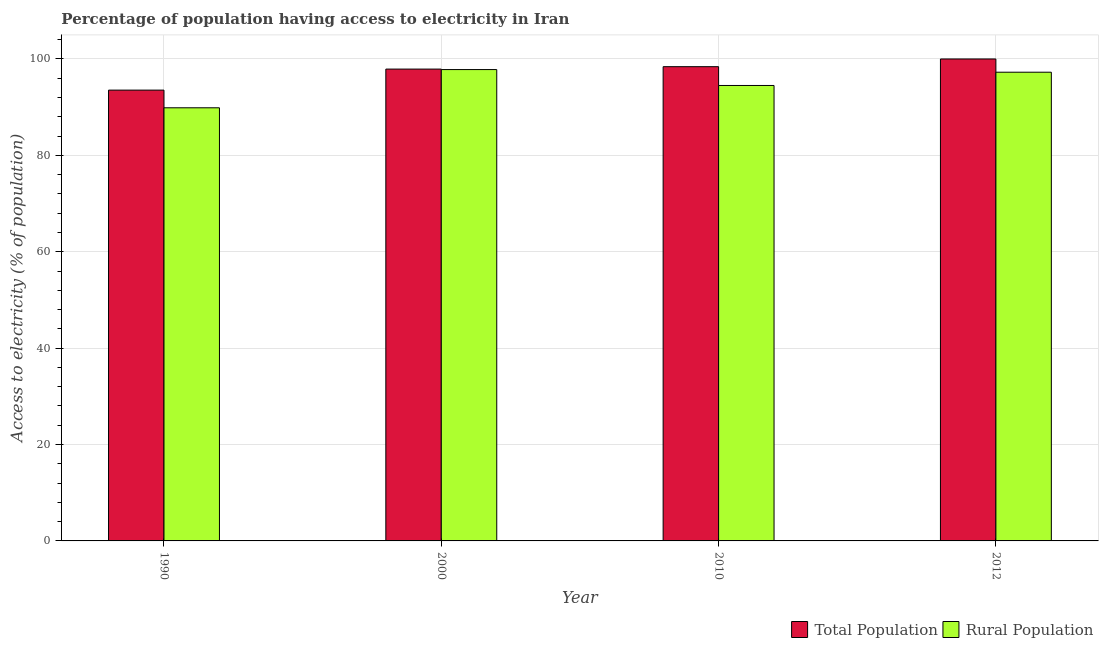Are the number of bars per tick equal to the number of legend labels?
Your answer should be compact. Yes. Are the number of bars on each tick of the X-axis equal?
Your answer should be very brief. Yes. How many bars are there on the 4th tick from the left?
Your answer should be very brief. 2. How many bars are there on the 4th tick from the right?
Make the answer very short. 2. What is the label of the 1st group of bars from the left?
Your answer should be very brief. 1990. What is the percentage of rural population having access to electricity in 2012?
Your answer should be compact. 97.25. Across all years, what is the maximum percentage of population having access to electricity?
Offer a very short reply. 100. Across all years, what is the minimum percentage of rural population having access to electricity?
Offer a very short reply. 89.87. In which year was the percentage of rural population having access to electricity maximum?
Your response must be concise. 2000. What is the total percentage of population having access to electricity in the graph?
Offer a terse response. 389.84. What is the difference between the percentage of rural population having access to electricity in 1990 and that in 2010?
Provide a short and direct response. -4.63. What is the difference between the percentage of population having access to electricity in 1990 and the percentage of rural population having access to electricity in 2010?
Give a very brief answer. -4.86. What is the average percentage of population having access to electricity per year?
Your answer should be compact. 97.46. In how many years, is the percentage of rural population having access to electricity greater than 4 %?
Keep it short and to the point. 4. What is the ratio of the percentage of rural population having access to electricity in 1990 to that in 2012?
Your answer should be very brief. 0.92. Is the difference between the percentage of rural population having access to electricity in 1990 and 2000 greater than the difference between the percentage of population having access to electricity in 1990 and 2000?
Offer a very short reply. No. What is the difference between the highest and the second highest percentage of population having access to electricity?
Provide a short and direct response. 1.6. What is the difference between the highest and the lowest percentage of population having access to electricity?
Provide a short and direct response. 6.46. In how many years, is the percentage of population having access to electricity greater than the average percentage of population having access to electricity taken over all years?
Give a very brief answer. 3. What does the 2nd bar from the left in 2010 represents?
Keep it short and to the point. Rural Population. What does the 1st bar from the right in 2010 represents?
Offer a terse response. Rural Population. How many bars are there?
Your answer should be compact. 8. Are all the bars in the graph horizontal?
Offer a terse response. No. How many years are there in the graph?
Your answer should be very brief. 4. Are the values on the major ticks of Y-axis written in scientific E-notation?
Provide a succinct answer. No. Where does the legend appear in the graph?
Ensure brevity in your answer.  Bottom right. How are the legend labels stacked?
Your answer should be very brief. Horizontal. What is the title of the graph?
Keep it short and to the point. Percentage of population having access to electricity in Iran. Does "Netherlands" appear as one of the legend labels in the graph?
Your answer should be compact. No. What is the label or title of the Y-axis?
Make the answer very short. Access to electricity (% of population). What is the Access to electricity (% of population) of Total Population in 1990?
Provide a short and direct response. 93.54. What is the Access to electricity (% of population) in Rural Population in 1990?
Keep it short and to the point. 89.87. What is the Access to electricity (% of population) of Total Population in 2000?
Your answer should be compact. 97.9. What is the Access to electricity (% of population) in Rural Population in 2000?
Make the answer very short. 97.8. What is the Access to electricity (% of population) in Total Population in 2010?
Your answer should be compact. 98.4. What is the Access to electricity (% of population) in Rural Population in 2010?
Give a very brief answer. 94.5. What is the Access to electricity (% of population) in Total Population in 2012?
Give a very brief answer. 100. What is the Access to electricity (% of population) in Rural Population in 2012?
Keep it short and to the point. 97.25. Across all years, what is the maximum Access to electricity (% of population) in Total Population?
Offer a terse response. 100. Across all years, what is the maximum Access to electricity (% of population) of Rural Population?
Your response must be concise. 97.8. Across all years, what is the minimum Access to electricity (% of population) in Total Population?
Make the answer very short. 93.54. Across all years, what is the minimum Access to electricity (% of population) in Rural Population?
Your response must be concise. 89.87. What is the total Access to electricity (% of population) of Total Population in the graph?
Your response must be concise. 389.84. What is the total Access to electricity (% of population) in Rural Population in the graph?
Your response must be concise. 379.42. What is the difference between the Access to electricity (% of population) in Total Population in 1990 and that in 2000?
Keep it short and to the point. -4.36. What is the difference between the Access to electricity (% of population) of Rural Population in 1990 and that in 2000?
Your answer should be compact. -7.93. What is the difference between the Access to electricity (% of population) of Total Population in 1990 and that in 2010?
Provide a short and direct response. -4.86. What is the difference between the Access to electricity (% of population) in Rural Population in 1990 and that in 2010?
Provide a short and direct response. -4.63. What is the difference between the Access to electricity (% of population) in Total Population in 1990 and that in 2012?
Provide a short and direct response. -6.46. What is the difference between the Access to electricity (% of population) of Rural Population in 1990 and that in 2012?
Offer a terse response. -7.38. What is the difference between the Access to electricity (% of population) of Rural Population in 2000 and that in 2010?
Your answer should be very brief. 3.3. What is the difference between the Access to electricity (% of population) in Rural Population in 2000 and that in 2012?
Offer a very short reply. 0.55. What is the difference between the Access to electricity (% of population) of Total Population in 2010 and that in 2012?
Offer a very short reply. -1.6. What is the difference between the Access to electricity (% of population) in Rural Population in 2010 and that in 2012?
Provide a short and direct response. -2.75. What is the difference between the Access to electricity (% of population) of Total Population in 1990 and the Access to electricity (% of population) of Rural Population in 2000?
Provide a short and direct response. -4.26. What is the difference between the Access to electricity (% of population) in Total Population in 1990 and the Access to electricity (% of population) in Rural Population in 2010?
Make the answer very short. -0.96. What is the difference between the Access to electricity (% of population) in Total Population in 1990 and the Access to electricity (% of population) in Rural Population in 2012?
Your response must be concise. -3.72. What is the difference between the Access to electricity (% of population) of Total Population in 2000 and the Access to electricity (% of population) of Rural Population in 2010?
Your answer should be very brief. 3.4. What is the difference between the Access to electricity (% of population) of Total Population in 2000 and the Access to electricity (% of population) of Rural Population in 2012?
Provide a succinct answer. 0.65. What is the difference between the Access to electricity (% of population) of Total Population in 2010 and the Access to electricity (% of population) of Rural Population in 2012?
Provide a succinct answer. 1.15. What is the average Access to electricity (% of population) of Total Population per year?
Your answer should be compact. 97.46. What is the average Access to electricity (% of population) of Rural Population per year?
Ensure brevity in your answer.  94.86. In the year 1990, what is the difference between the Access to electricity (% of population) of Total Population and Access to electricity (% of population) of Rural Population?
Your answer should be compact. 3.67. In the year 2010, what is the difference between the Access to electricity (% of population) in Total Population and Access to electricity (% of population) in Rural Population?
Your response must be concise. 3.9. In the year 2012, what is the difference between the Access to electricity (% of population) of Total Population and Access to electricity (% of population) of Rural Population?
Offer a very short reply. 2.75. What is the ratio of the Access to electricity (% of population) in Total Population in 1990 to that in 2000?
Offer a terse response. 0.96. What is the ratio of the Access to electricity (% of population) of Rural Population in 1990 to that in 2000?
Give a very brief answer. 0.92. What is the ratio of the Access to electricity (% of population) in Total Population in 1990 to that in 2010?
Provide a short and direct response. 0.95. What is the ratio of the Access to electricity (% of population) in Rural Population in 1990 to that in 2010?
Offer a terse response. 0.95. What is the ratio of the Access to electricity (% of population) of Total Population in 1990 to that in 2012?
Your answer should be very brief. 0.94. What is the ratio of the Access to electricity (% of population) of Rural Population in 1990 to that in 2012?
Make the answer very short. 0.92. What is the ratio of the Access to electricity (% of population) of Rural Population in 2000 to that in 2010?
Offer a very short reply. 1.03. What is the ratio of the Access to electricity (% of population) of Total Population in 2000 to that in 2012?
Offer a terse response. 0.98. What is the ratio of the Access to electricity (% of population) in Rural Population in 2000 to that in 2012?
Keep it short and to the point. 1.01. What is the ratio of the Access to electricity (% of population) of Rural Population in 2010 to that in 2012?
Provide a succinct answer. 0.97. What is the difference between the highest and the second highest Access to electricity (% of population) in Total Population?
Provide a short and direct response. 1.6. What is the difference between the highest and the second highest Access to electricity (% of population) in Rural Population?
Keep it short and to the point. 0.55. What is the difference between the highest and the lowest Access to electricity (% of population) of Total Population?
Ensure brevity in your answer.  6.46. What is the difference between the highest and the lowest Access to electricity (% of population) of Rural Population?
Provide a succinct answer. 7.93. 